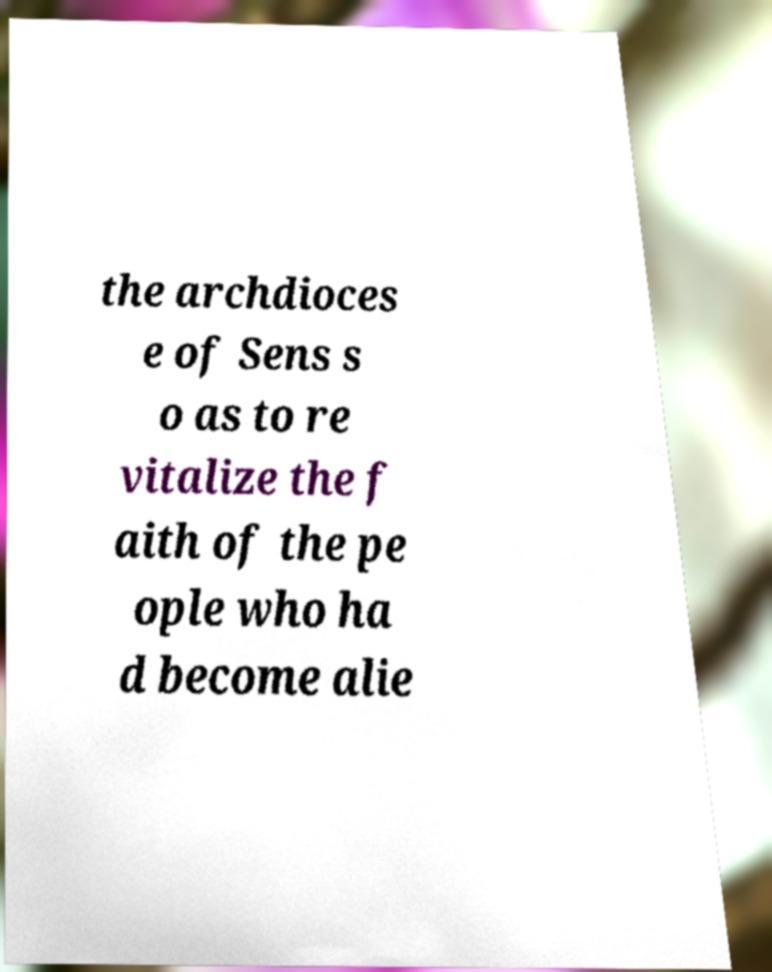Could you extract and type out the text from this image? the archdioces e of Sens s o as to re vitalize the f aith of the pe ople who ha d become alie 